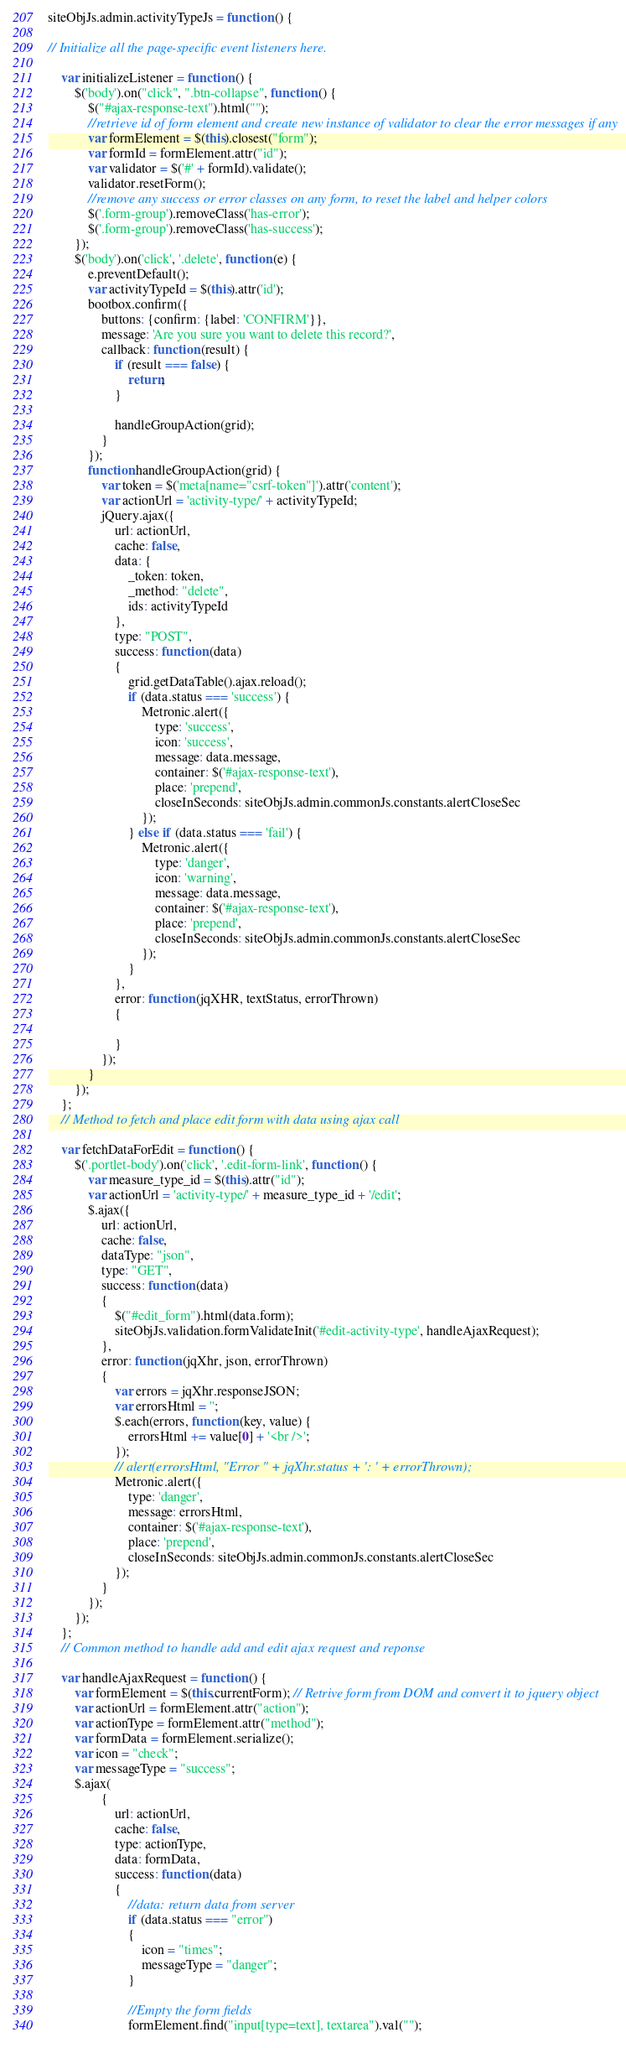<code> <loc_0><loc_0><loc_500><loc_500><_JavaScript_>siteObjJs.admin.activityTypeJs = function () {

// Initialize all the page-specific event listeners here.

    var initializeListener = function () {
        $('body').on("click", ".btn-collapse", function () {
            $("#ajax-response-text").html("");
            //retrieve id of form element and create new instance of validator to clear the error messages if any
            var formElement = $(this).closest("form");
            var formId = formElement.attr("id");
            var validator = $('#' + formId).validate();
            validator.resetForm();
            //remove any success or error classes on any form, to reset the label and helper colors
            $('.form-group').removeClass('has-error');
            $('.form-group').removeClass('has-success');
        });
        $('body').on('click', '.delete', function (e) {
            e.preventDefault();
            var activityTypeId = $(this).attr('id');
            bootbox.confirm({
                buttons: {confirm: {label: 'CONFIRM'}},
                message: 'Are you sure you want to delete this record?',
                callback: function (result) {
                    if (result === false) {
                        return;
                    }

                    handleGroupAction(grid);
                }
            });
            function handleGroupAction(grid) {
                var token = $('meta[name="csrf-token"]').attr('content');
                var actionUrl = 'activity-type/' + activityTypeId;
                jQuery.ajax({
                    url: actionUrl,
                    cache: false,
                    data: {
                        _token: token,
                        _method: "delete",
                        ids: activityTypeId
                    },
                    type: "POST",
                    success: function (data)
                    {
                        grid.getDataTable().ajax.reload();
                        if (data.status === 'success') {
                            Metronic.alert({
                                type: 'success',
                                icon: 'success',
                                message: data.message,
                                container: $('#ajax-response-text'),
                                place: 'prepend',
                                closeInSeconds: siteObjJs.admin.commonJs.constants.alertCloseSec
                            });
                        } else if (data.status === 'fail') {
                            Metronic.alert({
                                type: 'danger',
                                icon: 'warning',
                                message: data.message,
                                container: $('#ajax-response-text'),
                                place: 'prepend',
                                closeInSeconds: siteObjJs.admin.commonJs.constants.alertCloseSec
                            });
                        }
                    },
                    error: function (jqXHR, textStatus, errorThrown)
                    {

                    }
                });
            }
        });
    };
    // Method to fetch and place edit form with data using ajax call

    var fetchDataForEdit = function () {
        $('.portlet-body').on('click', '.edit-form-link', function () {
            var measure_type_id = $(this).attr("id");
            var actionUrl = 'activity-type/' + measure_type_id + '/edit';
            $.ajax({
                url: actionUrl,
                cache: false,
                dataType: "json",
                type: "GET",
                success: function (data)
                {
                    $("#edit_form").html(data.form);
                    siteObjJs.validation.formValidateInit('#edit-activity-type', handleAjaxRequest);
                },
                error: function (jqXhr, json, errorThrown)
                {
                    var errors = jqXhr.responseJSON;
                    var errorsHtml = '';
                    $.each(errors, function (key, value) {
                        errorsHtml += value[0] + '<br />';
                    });
                    // alert(errorsHtml, "Error " + jqXhr.status + ': ' + errorThrown);
                    Metronic.alert({
                        type: 'danger',
                        message: errorsHtml,
                        container: $('#ajax-response-text'),
                        place: 'prepend',
                        closeInSeconds: siteObjJs.admin.commonJs.constants.alertCloseSec
                    });
                }
            });
        });
    };
    // Common method to handle add and edit ajax request and reponse

    var handleAjaxRequest = function () {
        var formElement = $(this.currentForm); // Retrive form from DOM and convert it to jquery object
        var actionUrl = formElement.attr("action");
        var actionType = formElement.attr("method");
        var formData = formElement.serialize();
        var icon = "check";
        var messageType = "success";
        $.ajax(
                {
                    url: actionUrl,
                    cache: false,
                    type: actionType,
                    data: formData,
                    success: function (data)
                    {
                        //data: return data from server
                        if (data.status === "error")
                        {
                            icon = "times";
                            messageType = "danger";
                        }

                        //Empty the form fields
                        formElement.find("input[type=text], textarea").val("");</code> 